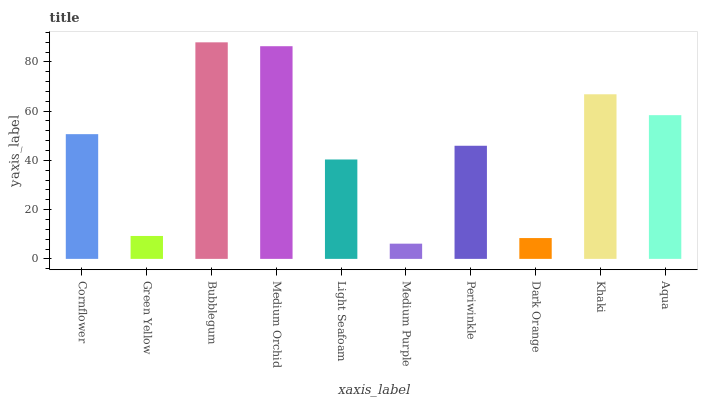Is Medium Purple the minimum?
Answer yes or no. Yes. Is Bubblegum the maximum?
Answer yes or no. Yes. Is Green Yellow the minimum?
Answer yes or no. No. Is Green Yellow the maximum?
Answer yes or no. No. Is Cornflower greater than Green Yellow?
Answer yes or no. Yes. Is Green Yellow less than Cornflower?
Answer yes or no. Yes. Is Green Yellow greater than Cornflower?
Answer yes or no. No. Is Cornflower less than Green Yellow?
Answer yes or no. No. Is Cornflower the high median?
Answer yes or no. Yes. Is Periwinkle the low median?
Answer yes or no. Yes. Is Medium Purple the high median?
Answer yes or no. No. Is Dark Orange the low median?
Answer yes or no. No. 